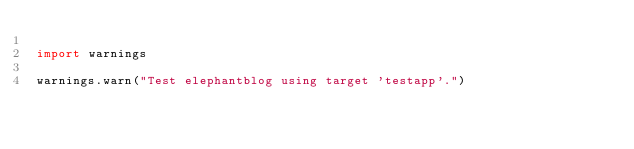<code> <loc_0><loc_0><loc_500><loc_500><_Python_>
import warnings

warnings.warn("Test elephantblog using target 'testapp'.")
</code> 